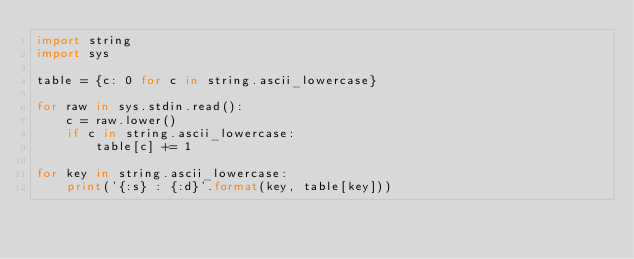Convert code to text. <code><loc_0><loc_0><loc_500><loc_500><_Python_>import string
import sys

table = {c: 0 for c in string.ascii_lowercase}

for raw in sys.stdin.read():
    c = raw.lower()
    if c in string.ascii_lowercase:
        table[c] += 1

for key in string.ascii_lowercase:
    print('{:s} : {:d}'.format(key, table[key]))</code> 